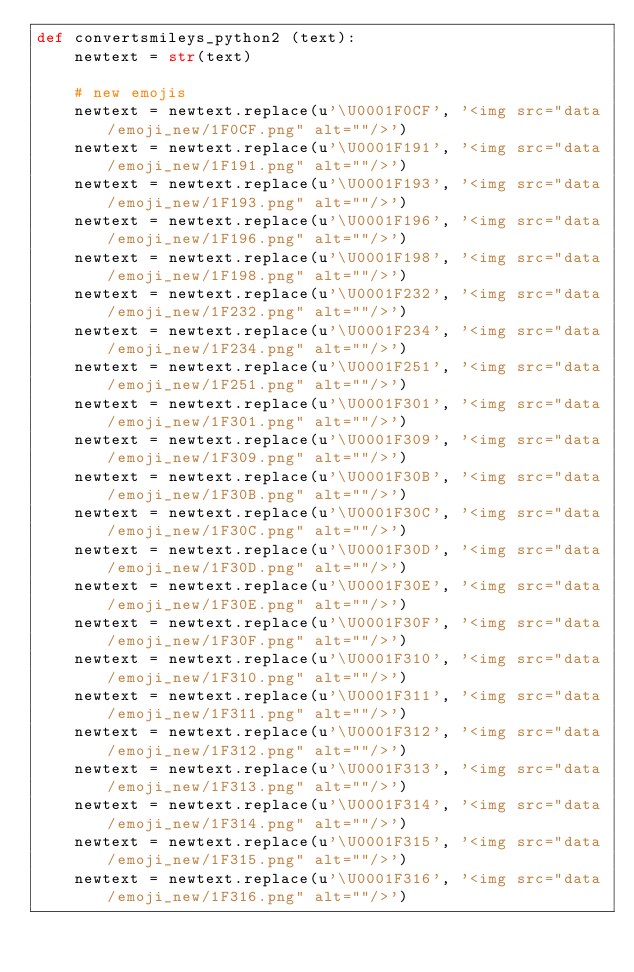<code> <loc_0><loc_0><loc_500><loc_500><_Python_>def convertsmileys_python2 (text):
    newtext = str(text)
    
    # new emojis
    newtext = newtext.replace(u'\U0001F0CF', '<img src="data/emoji_new/1F0CF.png" alt=""/>')
    newtext = newtext.replace(u'\U0001F191', '<img src="data/emoji_new/1F191.png" alt=""/>')
    newtext = newtext.replace(u'\U0001F193', '<img src="data/emoji_new/1F193.png" alt=""/>')
    newtext = newtext.replace(u'\U0001F196', '<img src="data/emoji_new/1F196.png" alt=""/>')
    newtext = newtext.replace(u'\U0001F198', '<img src="data/emoji_new/1F198.png" alt=""/>')
    newtext = newtext.replace(u'\U0001F232', '<img src="data/emoji_new/1F232.png" alt=""/>')
    newtext = newtext.replace(u'\U0001F234', '<img src="data/emoji_new/1F234.png" alt=""/>')
    newtext = newtext.replace(u'\U0001F251', '<img src="data/emoji_new/1F251.png" alt=""/>')
    newtext = newtext.replace(u'\U0001F301', '<img src="data/emoji_new/1F301.png" alt=""/>')
    newtext = newtext.replace(u'\U0001F309', '<img src="data/emoji_new/1F309.png" alt=""/>')
    newtext = newtext.replace(u'\U0001F30B', '<img src="data/emoji_new/1F30B.png" alt=""/>')
    newtext = newtext.replace(u'\U0001F30C', '<img src="data/emoji_new/1F30C.png" alt=""/>')
    newtext = newtext.replace(u'\U0001F30D', '<img src="data/emoji_new/1F30D.png" alt=""/>')
    newtext = newtext.replace(u'\U0001F30E', '<img src="data/emoji_new/1F30E.png" alt=""/>')
    newtext = newtext.replace(u'\U0001F30F', '<img src="data/emoji_new/1F30F.png" alt=""/>')
    newtext = newtext.replace(u'\U0001F310', '<img src="data/emoji_new/1F310.png" alt=""/>')
    newtext = newtext.replace(u'\U0001F311', '<img src="data/emoji_new/1F311.png" alt=""/>')
    newtext = newtext.replace(u'\U0001F312', '<img src="data/emoji_new/1F312.png" alt=""/>')
    newtext = newtext.replace(u'\U0001F313', '<img src="data/emoji_new/1F313.png" alt=""/>')
    newtext = newtext.replace(u'\U0001F314', '<img src="data/emoji_new/1F314.png" alt=""/>')
    newtext = newtext.replace(u'\U0001F315', '<img src="data/emoji_new/1F315.png" alt=""/>')
    newtext = newtext.replace(u'\U0001F316', '<img src="data/emoji_new/1F316.png" alt=""/>')</code> 